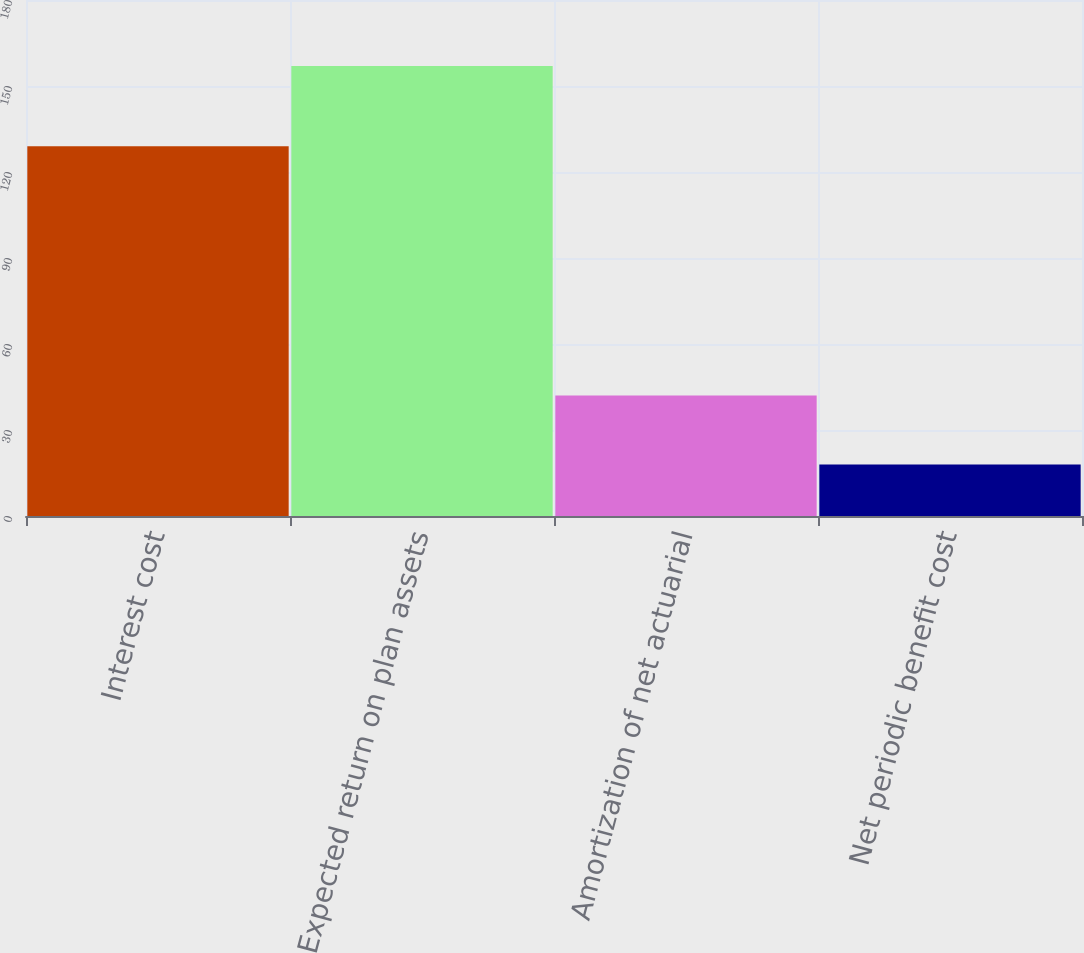Convert chart to OTSL. <chart><loc_0><loc_0><loc_500><loc_500><bar_chart><fcel>Interest cost<fcel>Expected return on plan assets<fcel>Amortization of net actuarial<fcel>Net periodic benefit cost<nl><fcel>129<fcel>157<fcel>42<fcel>18<nl></chart> 